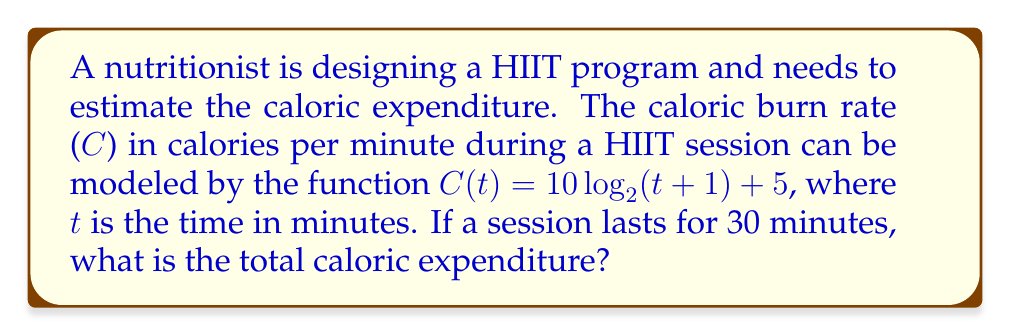Show me your answer to this math problem. To solve this problem, we need to follow these steps:

1) The caloric burn rate is given by the function:
   $C(t) = 10 \log_2(t+1) + 5$

2) To find the total caloric expenditure, we need to integrate this function over the duration of the session (30 minutes):

   $\text{Total Calories} = \int_0^{30} C(t) dt = \int_0^{30} (10 \log_2(t+1) + 5) dt$

3) Let's solve this integral:
   $\int_0^{30} (10 \log_2(t+1) + 5) dt$
   $= 10 \int_0^{30} \log_2(t+1) dt + 5 \int_0^{30} dt$

4) For the logarithmic part, we can use the substitution $u = t+1$, $du = dt$:
   $10 \int_1^{31} \log_2(u) du + 5t|_0^{30}$

5) The integral of $\log_2(u)$ is $\frac{u \log_2(u) - u}{\ln(2)}$:
   $10 [\frac{u \log_2(u) - u}{\ln(2)}]_1^{31} + 5(30)$

6) Evaluating:
   $10 [\frac{31 \log_2(31) - 31}{\ln(2)} - \frac{1 \log_2(1) - 1}{\ln(2)}] + 150$
   $= \frac{10}{\ln(2)} [31 \log_2(31) - 31 + 1] + 150$
   $\approx 459.6 + 150 = 609.6$

Therefore, the total caloric expenditure during the 30-minute HIIT session is approximately 609.6 calories.
Answer: 609.6 calories 